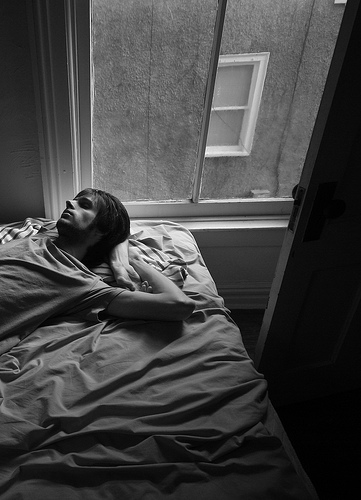Are there any blankets or beds? Yes, there are blankets and a bed. 